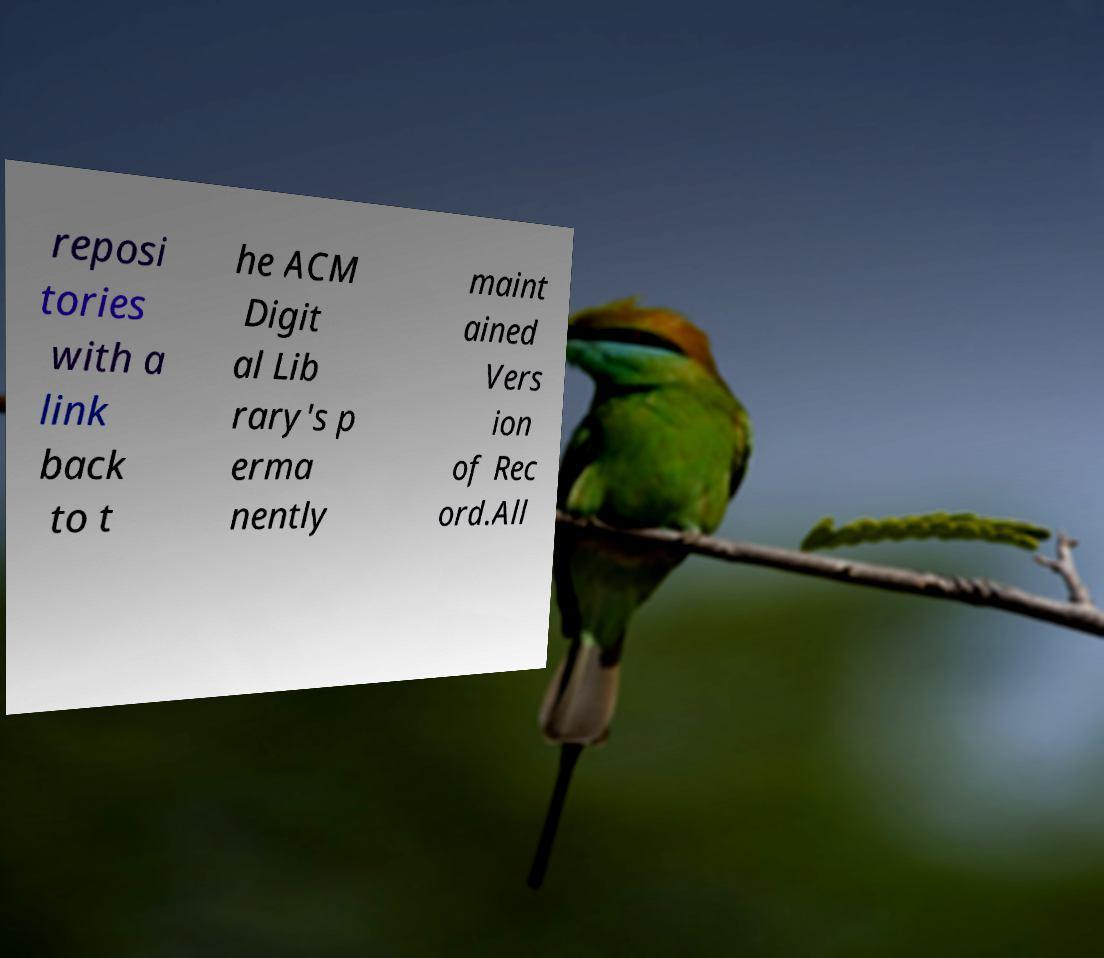There's text embedded in this image that I need extracted. Can you transcribe it verbatim? reposi tories with a link back to t he ACM Digit al Lib rary's p erma nently maint ained Vers ion of Rec ord.All 